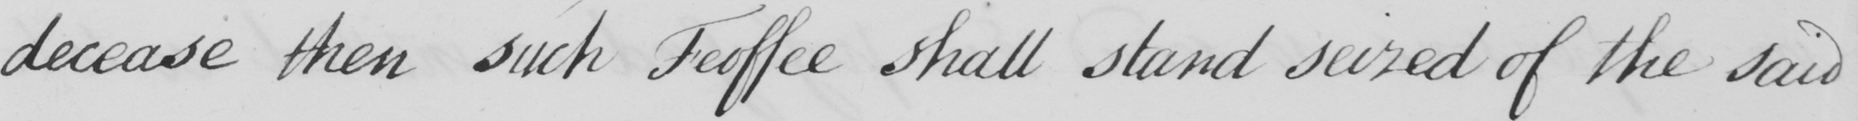Please transcribe the handwritten text in this image. decease then such Feoffee shall stand seized of the said 